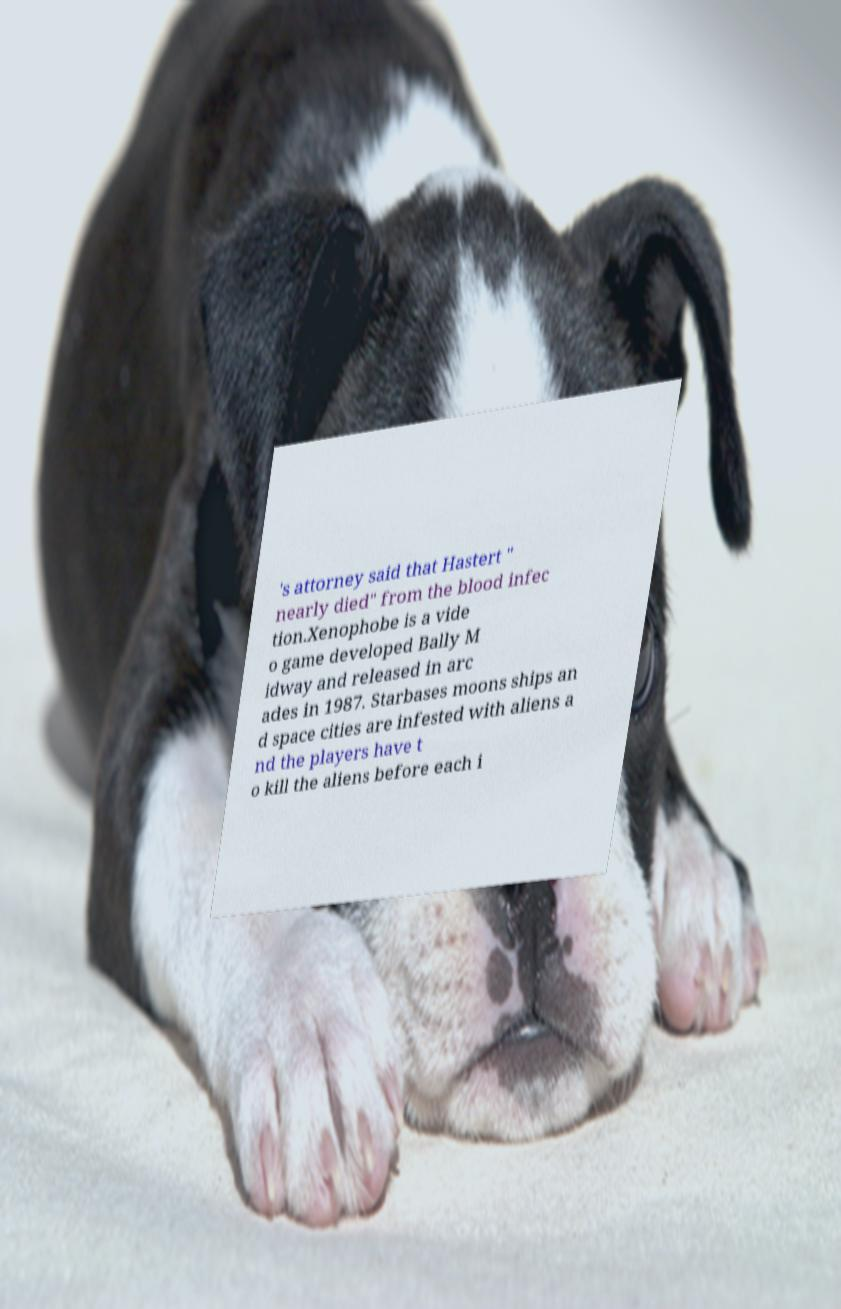I need the written content from this picture converted into text. Can you do that? 's attorney said that Hastert " nearly died" from the blood infec tion.Xenophobe is a vide o game developed Bally M idway and released in arc ades in 1987. Starbases moons ships an d space cities are infested with aliens a nd the players have t o kill the aliens before each i 